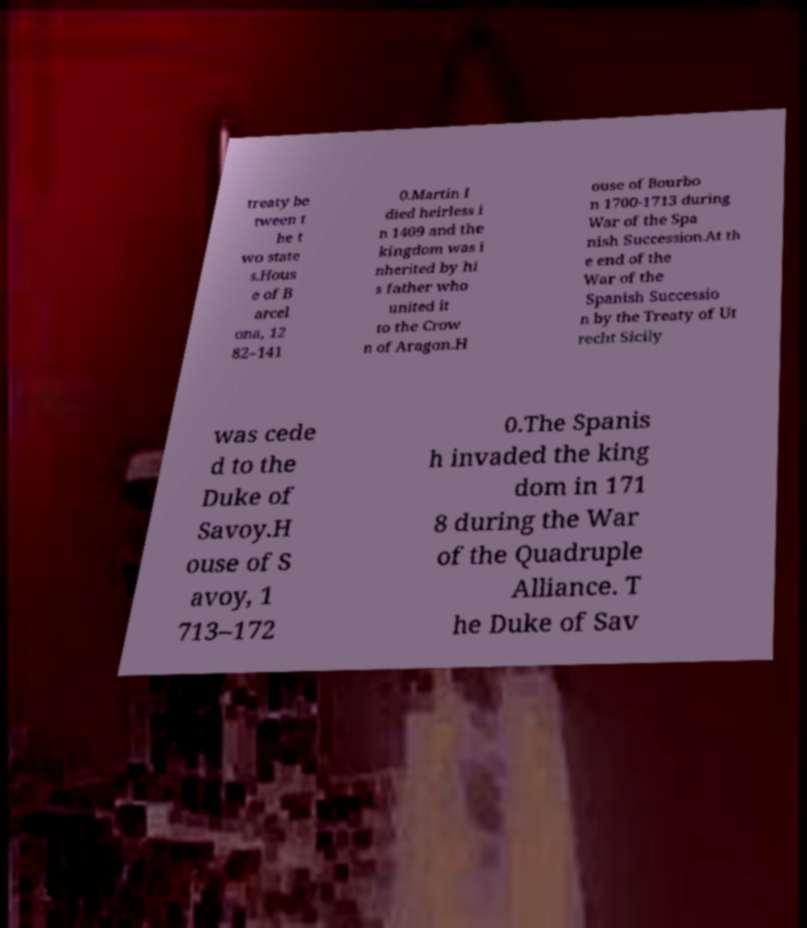There's text embedded in this image that I need extracted. Can you transcribe it verbatim? treaty be tween t he t wo state s.Hous e of B arcel ona, 12 82–141 0.Martin I died heirless i n 1409 and the kingdom was i nherited by hi s father who united it to the Crow n of Aragon.H ouse of Bourbo n 1700-1713 during War of the Spa nish Succession.At th e end of the War of the Spanish Successio n by the Treaty of Ut recht Sicily was cede d to the Duke of Savoy.H ouse of S avoy, 1 713–172 0.The Spanis h invaded the king dom in 171 8 during the War of the Quadruple Alliance. T he Duke of Sav 